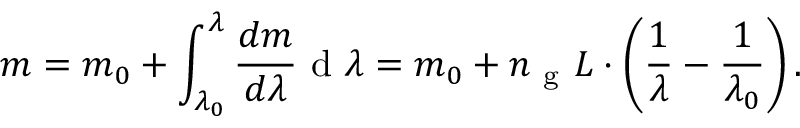<formula> <loc_0><loc_0><loc_500><loc_500>m = m _ { 0 } + \int _ { \lambda _ { 0 } } ^ { \lambda } \frac { d m } { d \lambda } d \lambda = m _ { 0 } + n _ { g } L \cdot \left ( \frac { 1 } { \lambda } - \frac { 1 } { \lambda _ { 0 } } \right ) .</formula> 